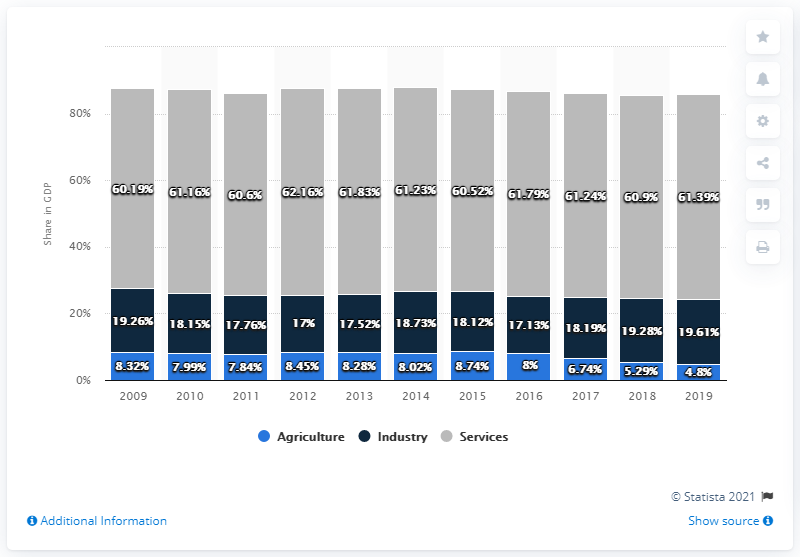Highlight a few significant elements in this photo. In 2019, the contribution of agriculture to Cabo Verde's gross domestic product was 4.8%. 